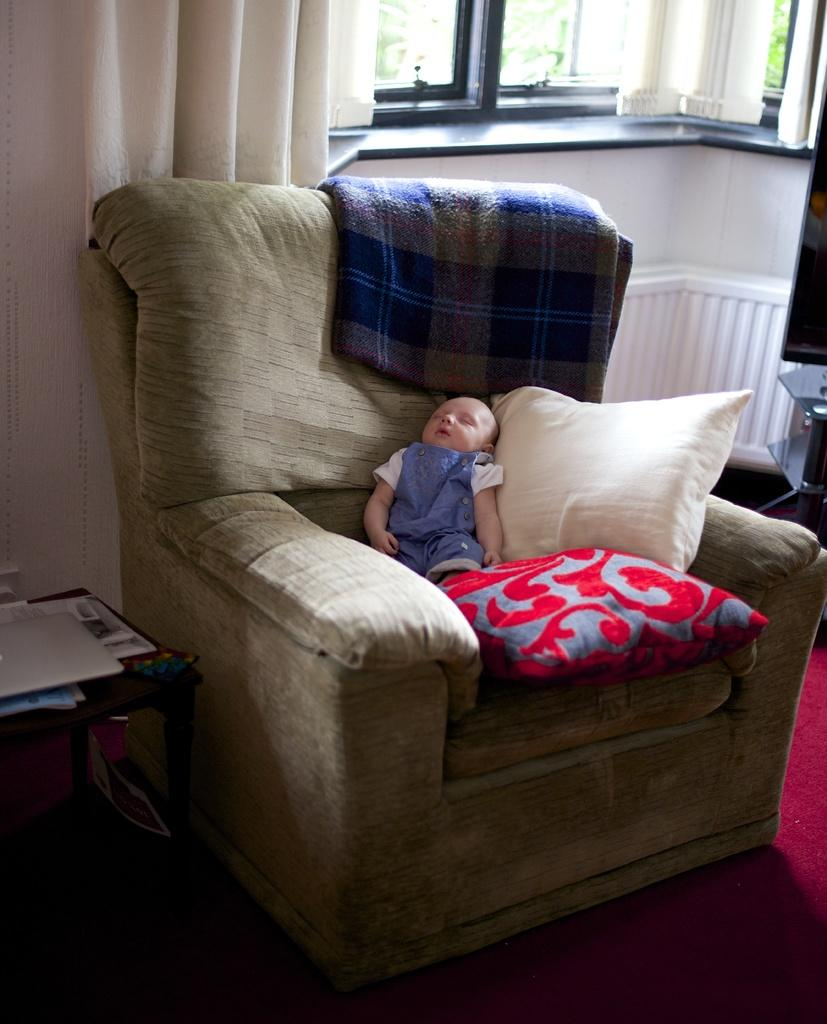What is the main subject of the image? There is a baby sleeping in the image. Where is the baby positioned in the image? The baby is on a chair. Are there any additional items near the chair? Yes, there are two pillows on the side of the chair. What can be seen in the background of the image? There is a window and a curtain hanging near the window. What type of feast is being prepared in the image? There is no indication of a feast or any food preparation in the image; it primarily features a baby sleeping on a chair. 